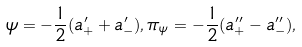Convert formula to latex. <formula><loc_0><loc_0><loc_500><loc_500>\psi = - \frac { 1 } { 2 } ( a _ { + } ^ { \prime } + a _ { - } ^ { \prime } ) , \pi _ { \psi } = - \frac { 1 } { 2 } ( a _ { + } ^ { \prime \prime } - a _ { - } ^ { \prime \prime } ) ,</formula> 